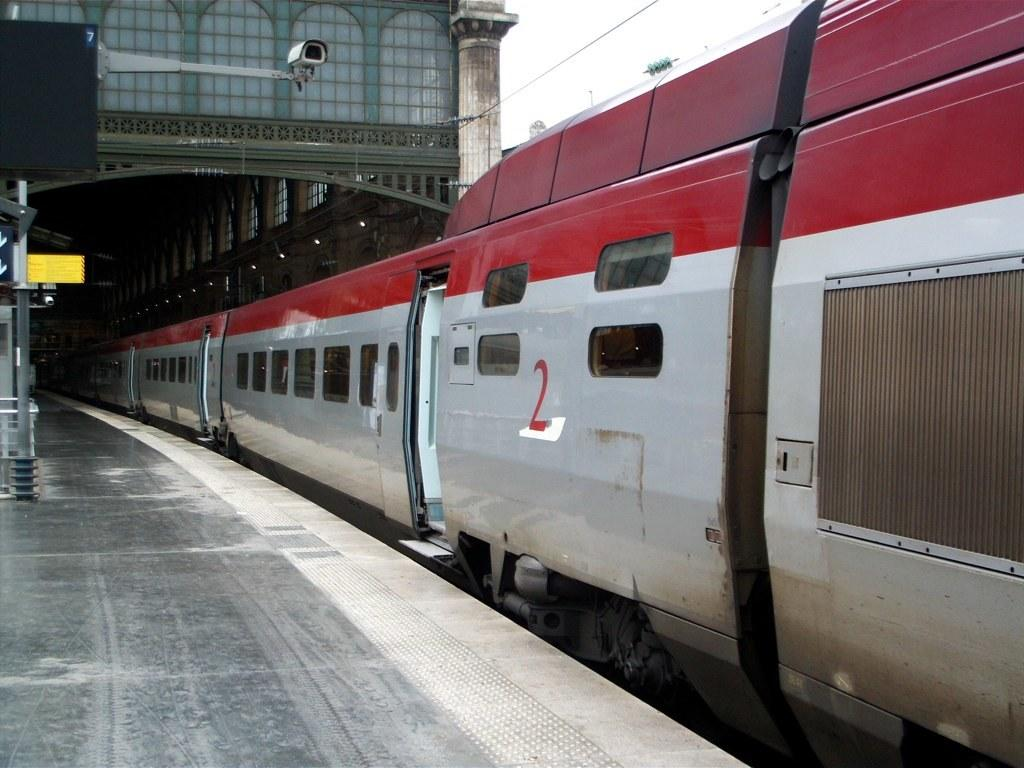What type of vehicle is in the image? There is a silver and red color train in the image. Where is the train located? The train is on a railway station. What material is used for the frame in the image? There is a metal frame visible in the image. What type of window is present in the image? There is a glass window in the image. What security device can be seen in the image? There is a white color CCTV camera in the image. What type of humor can be seen in the image? There is no humor present in the image; it features a train on a railway station with a metal frame, glass window, and CCTV camera. 